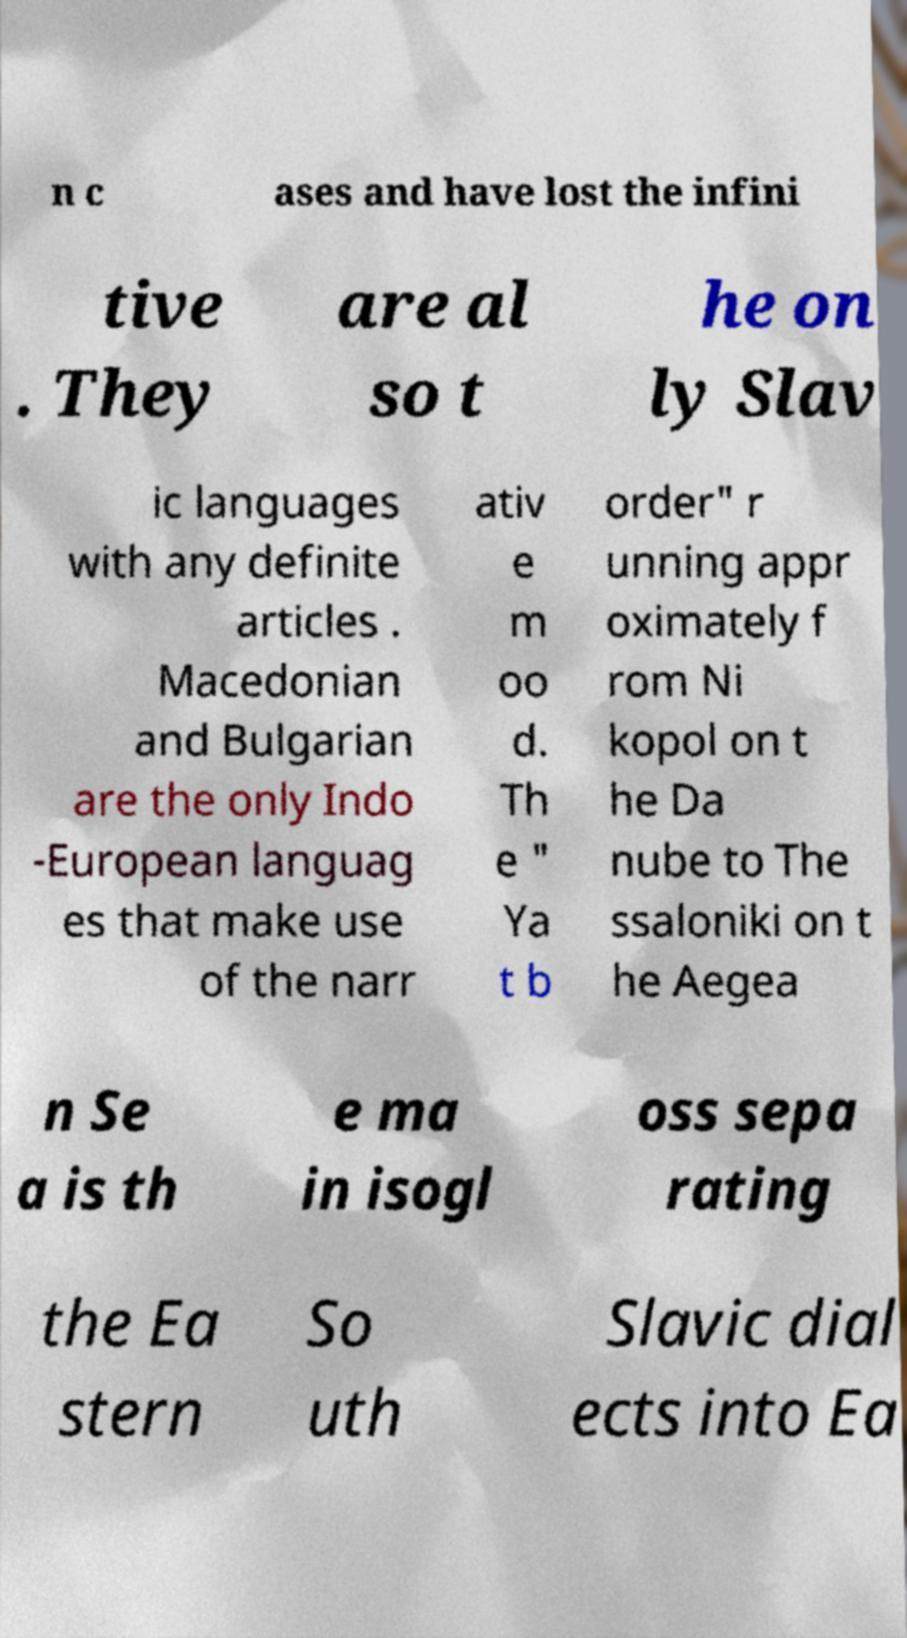For documentation purposes, I need the text within this image transcribed. Could you provide that? n c ases and have lost the infini tive . They are al so t he on ly Slav ic languages with any definite articles . Macedonian and Bulgarian are the only Indo -European languag es that make use of the narr ativ e m oo d. Th e " Ya t b order" r unning appr oximately f rom Ni kopol on t he Da nube to The ssaloniki on t he Aegea n Se a is th e ma in isogl oss sepa rating the Ea stern So uth Slavic dial ects into Ea 